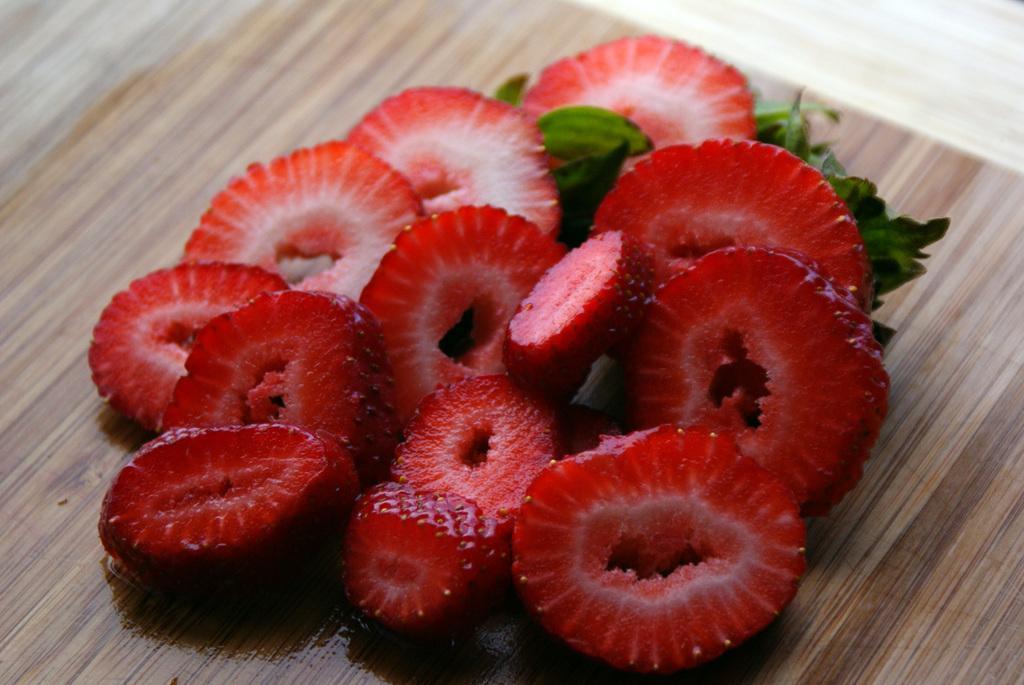Can you describe this image briefly? In this image we can see strawberry slices and leaves on the wooden plank. 